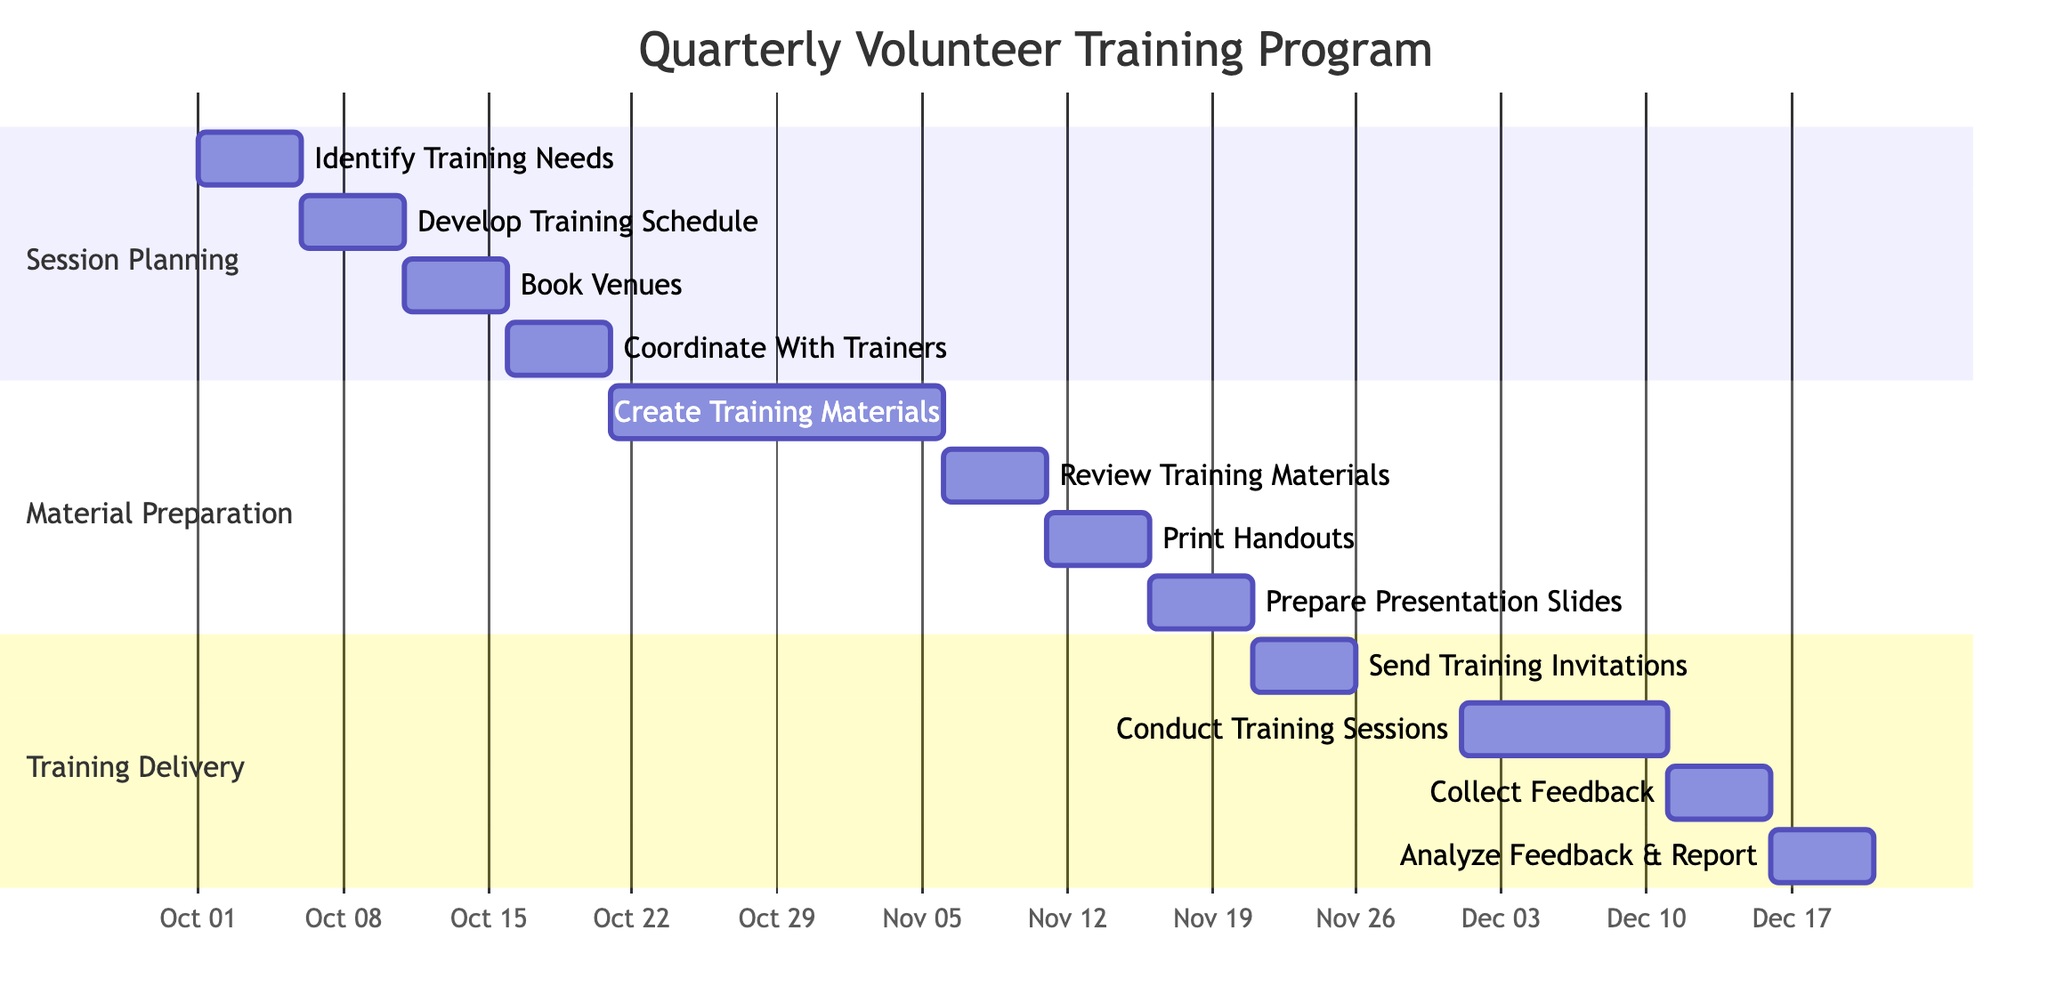What is the total number of tasks in the Gantt chart? There are three sections: Session Planning has 4 tasks, Material Preparation has 4 tasks, and Training Delivery has 4 tasks. Therefore, the total number of tasks is 4 + 4 + 4 = 12.
Answer: 12 Which task is assigned to Jane Doe? From the Session Planning section, the first task "Identify Training Needs" is assigned to Jane Doe.
Answer: Identify Training Needs What is the duration of the task "Conduct Training Sessions"? The "Conduct Training Sessions" task starts on December 1, 2023, and ends on December 10, 2023, which is a total of 10 days.
Answer: 10 days Who is responsible for reviewing the training materials? The task "Review Training Materials" is assigned to Mark Wilson, as indicated in the Material Preparation section.
Answer: Mark Wilson What comes after the task "Prepare Presentation Slides"? The task that follows "Prepare Presentation Slides" is "Send Training Invitations." This is found in the Training Delivery section.
Answer: Send Training Invitations Which task has the longest duration in the Gantt chart? The task "Create Training Materials" has a duration of 16 days, which is the longest among all tasks when calculating the time span from October 21 to November 5, 2023.
Answer: Create Training Materials At what date does the "Analyze Feedback & Report" task start? The task "Analyze Feedback & Report" begins on December 16, 2023, as shown in its timeline.
Answer: December 16, 2023 How many days does the entire training program take from start to finish? The training program begins with "Identify Training Needs" on October 1, 2023, and ends with "Analyze Feedback & Report" on December 20, 2023. This includes a duration of 81 days in total.
Answer: 81 days What task is scheduled at the same time as "Print Handouts"? The "Review Training Materials" task is scheduled at the same time as "Print Handouts," meaning both tasks occur sequentially and must align within their respective periods: November 6 to November 10, 2023, and November 11 to November 15, 2023.
Answer: None 